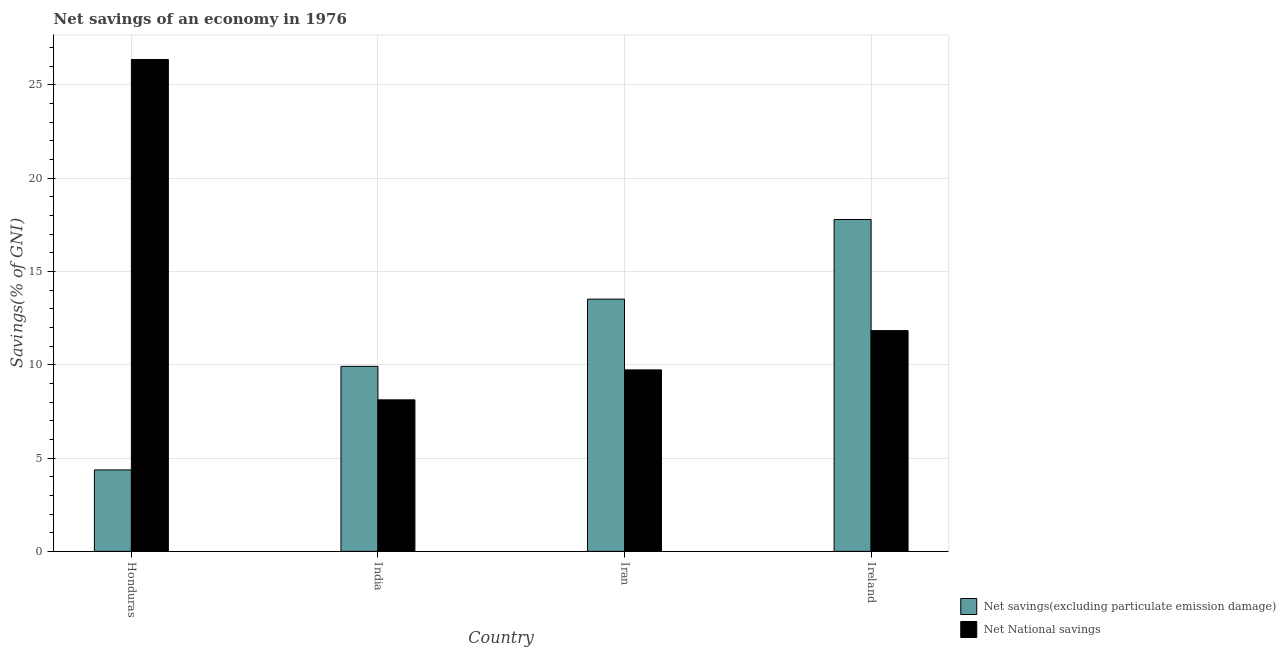What is the label of the 4th group of bars from the left?
Give a very brief answer. Ireland. In how many cases, is the number of bars for a given country not equal to the number of legend labels?
Make the answer very short. 0. What is the net national savings in India?
Your answer should be compact. 8.12. Across all countries, what is the maximum net national savings?
Offer a terse response. 26.36. Across all countries, what is the minimum net national savings?
Your answer should be compact. 8.12. In which country was the net savings(excluding particulate emission damage) maximum?
Your answer should be compact. Ireland. In which country was the net savings(excluding particulate emission damage) minimum?
Ensure brevity in your answer.  Honduras. What is the total net national savings in the graph?
Make the answer very short. 56.04. What is the difference between the net national savings in Honduras and that in Ireland?
Provide a short and direct response. 14.53. What is the difference between the net savings(excluding particulate emission damage) in Honduras and the net national savings in India?
Provide a succinct answer. -3.76. What is the average net savings(excluding particulate emission damage) per country?
Provide a short and direct response. 11.4. What is the difference between the net national savings and net savings(excluding particulate emission damage) in Ireland?
Offer a terse response. -5.95. What is the ratio of the net savings(excluding particulate emission damage) in India to that in Iran?
Offer a terse response. 0.73. What is the difference between the highest and the second highest net savings(excluding particulate emission damage)?
Offer a very short reply. 4.27. What is the difference between the highest and the lowest net national savings?
Provide a short and direct response. 18.24. In how many countries, is the net national savings greater than the average net national savings taken over all countries?
Ensure brevity in your answer.  1. Is the sum of the net national savings in India and Ireland greater than the maximum net savings(excluding particulate emission damage) across all countries?
Make the answer very short. Yes. What does the 1st bar from the left in Ireland represents?
Offer a very short reply. Net savings(excluding particulate emission damage). What does the 2nd bar from the right in India represents?
Make the answer very short. Net savings(excluding particulate emission damage). Are all the bars in the graph horizontal?
Offer a very short reply. No. What is the difference between two consecutive major ticks on the Y-axis?
Your response must be concise. 5. Are the values on the major ticks of Y-axis written in scientific E-notation?
Your answer should be very brief. No. Does the graph contain any zero values?
Provide a short and direct response. No. Does the graph contain grids?
Give a very brief answer. Yes. How many legend labels are there?
Keep it short and to the point. 2. What is the title of the graph?
Your answer should be compact. Net savings of an economy in 1976. What is the label or title of the Y-axis?
Ensure brevity in your answer.  Savings(% of GNI). What is the Savings(% of GNI) in Net savings(excluding particulate emission damage) in Honduras?
Your answer should be compact. 4.36. What is the Savings(% of GNI) in Net National savings in Honduras?
Keep it short and to the point. 26.36. What is the Savings(% of GNI) of Net savings(excluding particulate emission damage) in India?
Ensure brevity in your answer.  9.92. What is the Savings(% of GNI) in Net National savings in India?
Ensure brevity in your answer.  8.12. What is the Savings(% of GNI) in Net savings(excluding particulate emission damage) in Iran?
Your answer should be very brief. 13.52. What is the Savings(% of GNI) in Net National savings in Iran?
Your answer should be compact. 9.73. What is the Savings(% of GNI) in Net savings(excluding particulate emission damage) in Ireland?
Your answer should be very brief. 17.79. What is the Savings(% of GNI) in Net National savings in Ireland?
Make the answer very short. 11.83. Across all countries, what is the maximum Savings(% of GNI) in Net savings(excluding particulate emission damage)?
Your answer should be compact. 17.79. Across all countries, what is the maximum Savings(% of GNI) in Net National savings?
Your response must be concise. 26.36. Across all countries, what is the minimum Savings(% of GNI) of Net savings(excluding particulate emission damage)?
Provide a succinct answer. 4.36. Across all countries, what is the minimum Savings(% of GNI) of Net National savings?
Provide a short and direct response. 8.12. What is the total Savings(% of GNI) in Net savings(excluding particulate emission damage) in the graph?
Offer a terse response. 45.59. What is the total Savings(% of GNI) of Net National savings in the graph?
Give a very brief answer. 56.04. What is the difference between the Savings(% of GNI) in Net savings(excluding particulate emission damage) in Honduras and that in India?
Your answer should be compact. -5.55. What is the difference between the Savings(% of GNI) of Net National savings in Honduras and that in India?
Make the answer very short. 18.24. What is the difference between the Savings(% of GNI) in Net savings(excluding particulate emission damage) in Honduras and that in Iran?
Offer a very short reply. -9.15. What is the difference between the Savings(% of GNI) in Net National savings in Honduras and that in Iran?
Your answer should be very brief. 16.64. What is the difference between the Savings(% of GNI) in Net savings(excluding particulate emission damage) in Honduras and that in Ireland?
Ensure brevity in your answer.  -13.42. What is the difference between the Savings(% of GNI) in Net National savings in Honduras and that in Ireland?
Offer a terse response. 14.53. What is the difference between the Savings(% of GNI) of Net savings(excluding particulate emission damage) in India and that in Iran?
Your answer should be very brief. -3.6. What is the difference between the Savings(% of GNI) in Net National savings in India and that in Iran?
Make the answer very short. -1.61. What is the difference between the Savings(% of GNI) of Net savings(excluding particulate emission damage) in India and that in Ireland?
Give a very brief answer. -7.87. What is the difference between the Savings(% of GNI) of Net National savings in India and that in Ireland?
Provide a short and direct response. -3.71. What is the difference between the Savings(% of GNI) of Net savings(excluding particulate emission damage) in Iran and that in Ireland?
Provide a short and direct response. -4.27. What is the difference between the Savings(% of GNI) of Net National savings in Iran and that in Ireland?
Ensure brevity in your answer.  -2.11. What is the difference between the Savings(% of GNI) in Net savings(excluding particulate emission damage) in Honduras and the Savings(% of GNI) in Net National savings in India?
Provide a short and direct response. -3.76. What is the difference between the Savings(% of GNI) of Net savings(excluding particulate emission damage) in Honduras and the Savings(% of GNI) of Net National savings in Iran?
Your response must be concise. -5.36. What is the difference between the Savings(% of GNI) of Net savings(excluding particulate emission damage) in Honduras and the Savings(% of GNI) of Net National savings in Ireland?
Your response must be concise. -7.47. What is the difference between the Savings(% of GNI) in Net savings(excluding particulate emission damage) in India and the Savings(% of GNI) in Net National savings in Iran?
Make the answer very short. 0.19. What is the difference between the Savings(% of GNI) in Net savings(excluding particulate emission damage) in India and the Savings(% of GNI) in Net National savings in Ireland?
Provide a succinct answer. -1.92. What is the difference between the Savings(% of GNI) in Net savings(excluding particulate emission damage) in Iran and the Savings(% of GNI) in Net National savings in Ireland?
Your response must be concise. 1.69. What is the average Savings(% of GNI) of Net savings(excluding particulate emission damage) per country?
Make the answer very short. 11.4. What is the average Savings(% of GNI) of Net National savings per country?
Offer a very short reply. 14.01. What is the difference between the Savings(% of GNI) in Net savings(excluding particulate emission damage) and Savings(% of GNI) in Net National savings in Honduras?
Provide a short and direct response. -22. What is the difference between the Savings(% of GNI) in Net savings(excluding particulate emission damage) and Savings(% of GNI) in Net National savings in India?
Your answer should be very brief. 1.8. What is the difference between the Savings(% of GNI) in Net savings(excluding particulate emission damage) and Savings(% of GNI) in Net National savings in Iran?
Your answer should be compact. 3.79. What is the difference between the Savings(% of GNI) of Net savings(excluding particulate emission damage) and Savings(% of GNI) of Net National savings in Ireland?
Offer a very short reply. 5.95. What is the ratio of the Savings(% of GNI) in Net savings(excluding particulate emission damage) in Honduras to that in India?
Ensure brevity in your answer.  0.44. What is the ratio of the Savings(% of GNI) in Net National savings in Honduras to that in India?
Provide a short and direct response. 3.25. What is the ratio of the Savings(% of GNI) of Net savings(excluding particulate emission damage) in Honduras to that in Iran?
Provide a succinct answer. 0.32. What is the ratio of the Savings(% of GNI) of Net National savings in Honduras to that in Iran?
Your answer should be compact. 2.71. What is the ratio of the Savings(% of GNI) in Net savings(excluding particulate emission damage) in Honduras to that in Ireland?
Make the answer very short. 0.25. What is the ratio of the Savings(% of GNI) of Net National savings in Honduras to that in Ireland?
Provide a short and direct response. 2.23. What is the ratio of the Savings(% of GNI) in Net savings(excluding particulate emission damage) in India to that in Iran?
Provide a short and direct response. 0.73. What is the ratio of the Savings(% of GNI) of Net National savings in India to that in Iran?
Your answer should be very brief. 0.83. What is the ratio of the Savings(% of GNI) of Net savings(excluding particulate emission damage) in India to that in Ireland?
Keep it short and to the point. 0.56. What is the ratio of the Savings(% of GNI) in Net National savings in India to that in Ireland?
Provide a short and direct response. 0.69. What is the ratio of the Savings(% of GNI) of Net savings(excluding particulate emission damage) in Iran to that in Ireland?
Keep it short and to the point. 0.76. What is the ratio of the Savings(% of GNI) of Net National savings in Iran to that in Ireland?
Give a very brief answer. 0.82. What is the difference between the highest and the second highest Savings(% of GNI) in Net savings(excluding particulate emission damage)?
Provide a short and direct response. 4.27. What is the difference between the highest and the second highest Savings(% of GNI) in Net National savings?
Offer a very short reply. 14.53. What is the difference between the highest and the lowest Savings(% of GNI) in Net savings(excluding particulate emission damage)?
Your answer should be compact. 13.42. What is the difference between the highest and the lowest Savings(% of GNI) of Net National savings?
Ensure brevity in your answer.  18.24. 